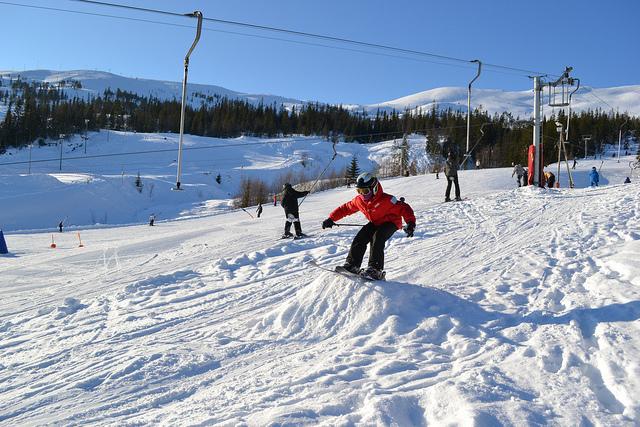What season is this?
Concise answer only. Winter. Do the skiers appear tired?
Keep it brief. No. What is on this person's feet?
Quick response, please. Skis. Why doesn't the sun melt the snow?
Write a very short answer. Cold. 